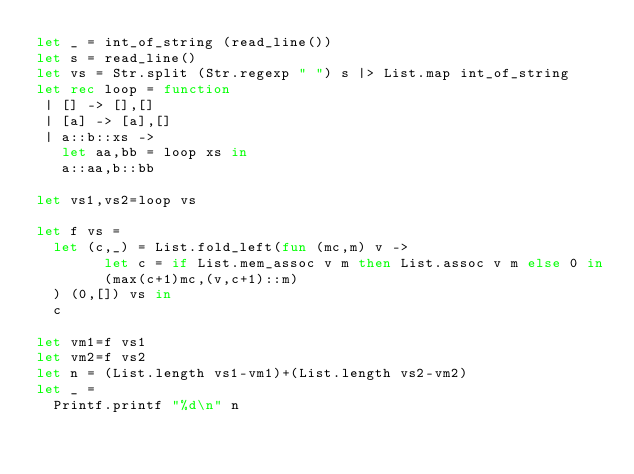Convert code to text. <code><loc_0><loc_0><loc_500><loc_500><_OCaml_>let _ = int_of_string (read_line())
let s = read_line()
let vs = Str.split (Str.regexp " ") s |> List.map int_of_string
let rec loop = function
 | [] -> [],[]
 | [a] -> [a],[]
 | a::b::xs ->
   let aa,bb = loop xs in
   a::aa,b::bb

let vs1,vs2=loop vs

let f vs =
  let (c,_) = List.fold_left(fun (mc,m) v ->
        let c = if List.mem_assoc v m then List.assoc v m else 0 in
        (max(c+1)mc,(v,c+1)::m)
  ) (0,[]) vs in
  c

let vm1=f vs1
let vm2=f vs2
let n = (List.length vs1-vm1)+(List.length vs2-vm2)
let _ =
  Printf.printf "%d\n" n
</code> 